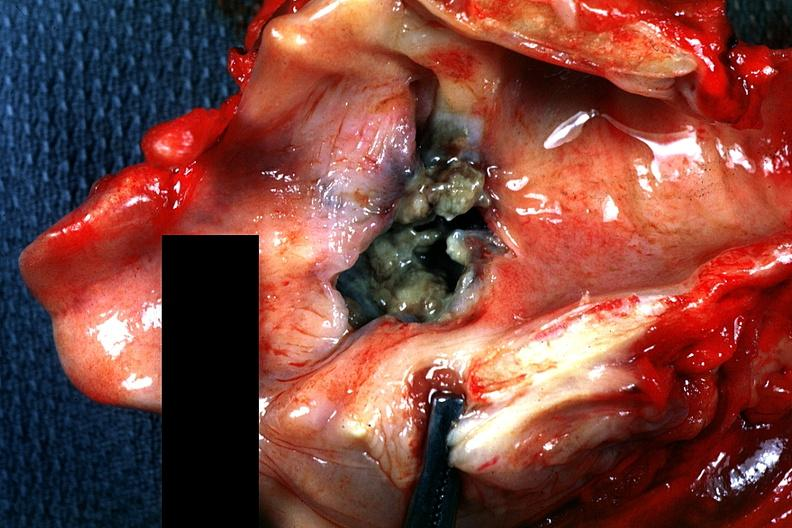what does this image show?
Answer the question using a single word or phrase. Large ulcerated and necrotic appearing lesion 